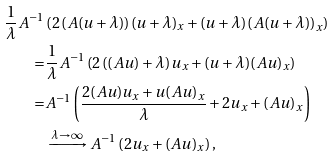Convert formula to latex. <formula><loc_0><loc_0><loc_500><loc_500>\frac { 1 } { \lambda } A ^ { - 1 } & \left ( 2 \left ( A ( u + \lambda ) \right ) ( u + \lambda ) _ { x } + ( u + \lambda ) \left ( A ( u + \lambda ) \right ) _ { x } \right ) \\ = & \frac { 1 } { \lambda } A ^ { - 1 } \left ( 2 \left ( ( A u ) + \lambda \right ) u _ { x } + ( u + \lambda ) ( A u ) _ { x } \right ) \\ = & A ^ { - 1 } \left ( \frac { 2 ( A u ) u _ { x } + u ( A u ) _ { x } } { \lambda } + 2 u _ { x } + ( A u ) _ { x } \right ) \\ & \xrightarrow { \lambda \to \infty } A ^ { - 1 } \left ( 2 u _ { x } + ( A u ) _ { x } \right ) ,</formula> 